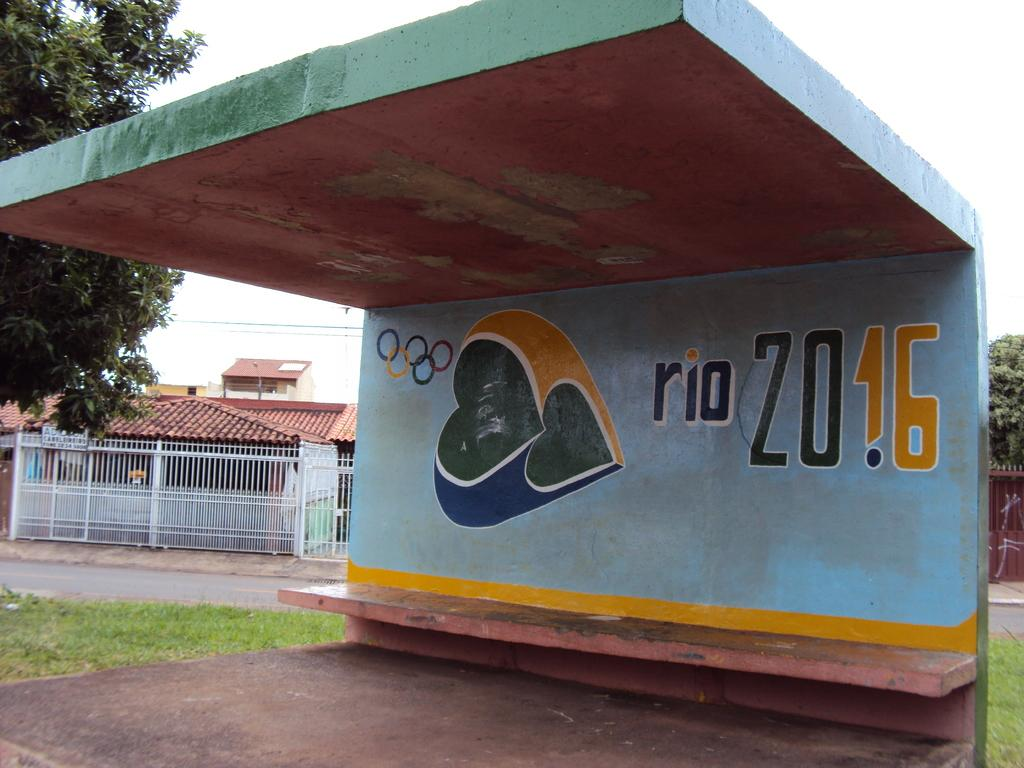What structure is located in the middle of the image? There is a shed in the middle of the image. What type of vegetation is behind the shed? There is grass behind the shed. What type of barrier is present in the image? There is fencing in the image. What type of man-made structures can be seen in the image? There are buildings in the image. What type of natural elements are present in the image? There are trees in the image. What is visible at the top of the image? The sky is visible at the top of the image. What type of cushion is used to support the trees in the image? There is no cushion present in the image; the trees are standing on the ground. 